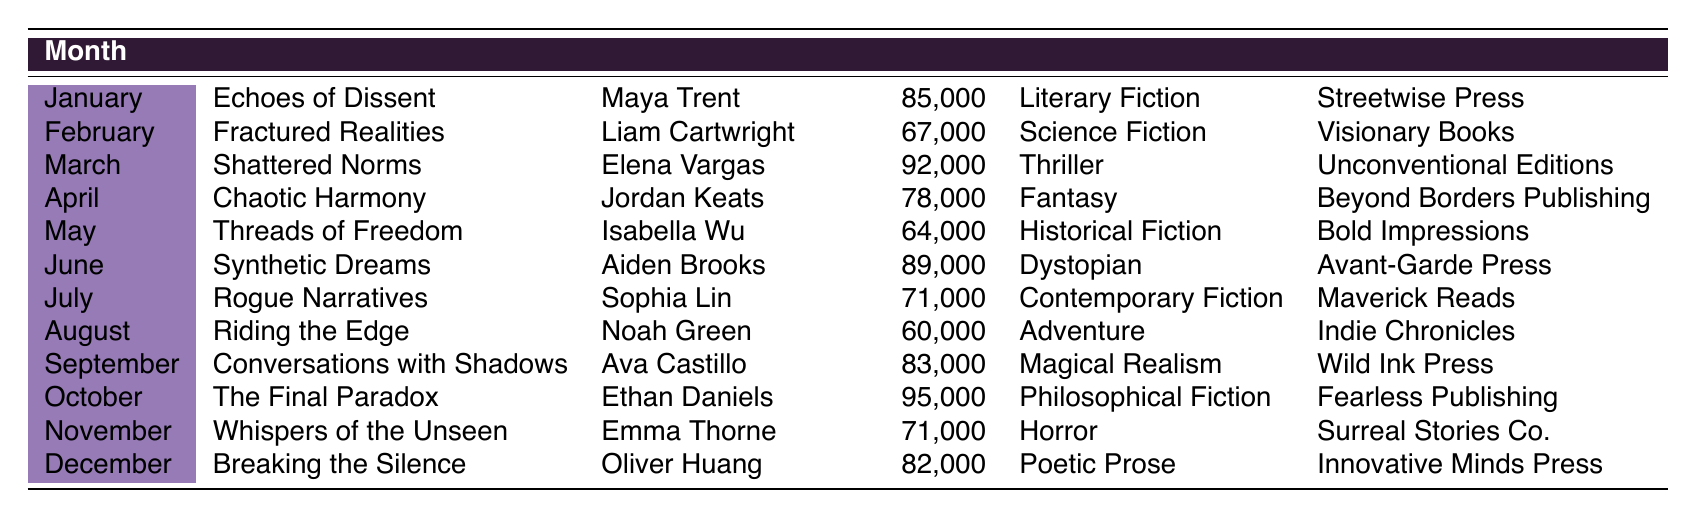What is the title of the novel published in October? According to the table, the month of October features the title "The Final Paradox."
Answer: The Final Paradox Who is the author of "Riding the Edge"? The table shows that "Riding the Edge" is authored by Noah Green.
Answer: Noah Green Which genre has the highest word count in the data? When comparing the word counts for each genre, "Philosophical Fiction" has the highest at 95,000 words, as indicated in the October entry.
Answer: Philosophical Fiction How many novels published in 2023 have a word count greater than 80,000? By analyzing the word counts, the novels with counts greater than 80,000 are: "Echoes of Dissent" (85,000), "Shattered Norms" (92,000), "Synthetic Dreams" (89,000), "The Final Paradox" (95,000), and "Breaking the Silence" (82,000). This totals to five novels.
Answer: 5 Is "Threads of Freedom" categorized as Science Fiction? The genre listed for "Threads of Freedom" is "Historical Fiction," thus categorizing it as something other than Science Fiction.
Answer: No What is the average word count of the novels published in May, June, and July? The word counts for these months are 64,000 (May), 89,000 (June), and 71,000 (July). Adding them gives 64,000 + 89,000 + 71,000 = 224,000. Dividing by 3 (the number of months) yields an average of 224,000 / 3 = approximately 74,667.
Answer: 74,667 Which author published the novel with the lowest word count, and what was that count? The novel with the lowest word count, found in August, is "Riding the Edge" by Noah Green with a count of 60,000.
Answer: Noah Green, 60,000 What is the difference in word count between "Conversations with Shadows" and "Synthetic Dreams"? "Conversations with Shadows" has a word count of 83,000 and "Synthetic Dreams" has 89,000. The difference is 89,000 - 83,000 = 6,000.
Answer: 6,000 